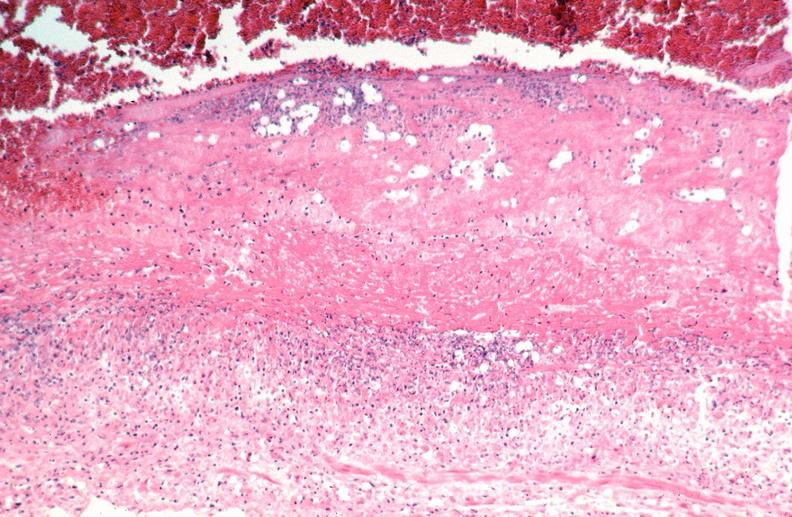what does this image show?
Answer the question using a single word or phrase. Vasculitis 